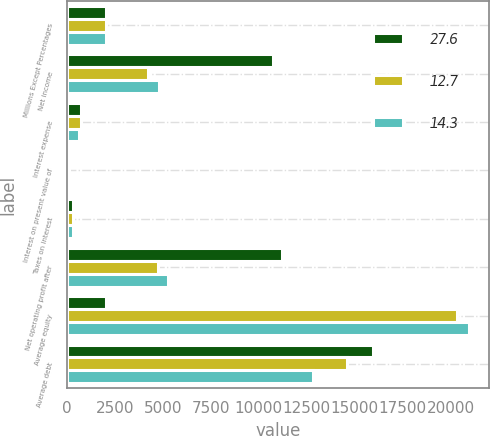Convert chart to OTSL. <chart><loc_0><loc_0><loc_500><loc_500><stacked_bar_chart><ecel><fcel>Millions Except Percentages<fcel>Net income<fcel>Interest expense<fcel>Interest on present value of<fcel>Taxes on interest<fcel>Net operating profit after<fcel>Average equity<fcel>Average debt<nl><fcel>27.6<fcel>2017<fcel>10712<fcel>719<fcel>105<fcel>309<fcel>11227<fcel>2017<fcel>15976<nl><fcel>12.7<fcel>2016<fcel>4233<fcel>698<fcel>121<fcel>306<fcel>4746<fcel>20317<fcel>14604<nl><fcel>14.3<fcel>2015<fcel>4772<fcel>622<fcel>135<fcel>285<fcel>5244<fcel>20946<fcel>12807<nl></chart> 